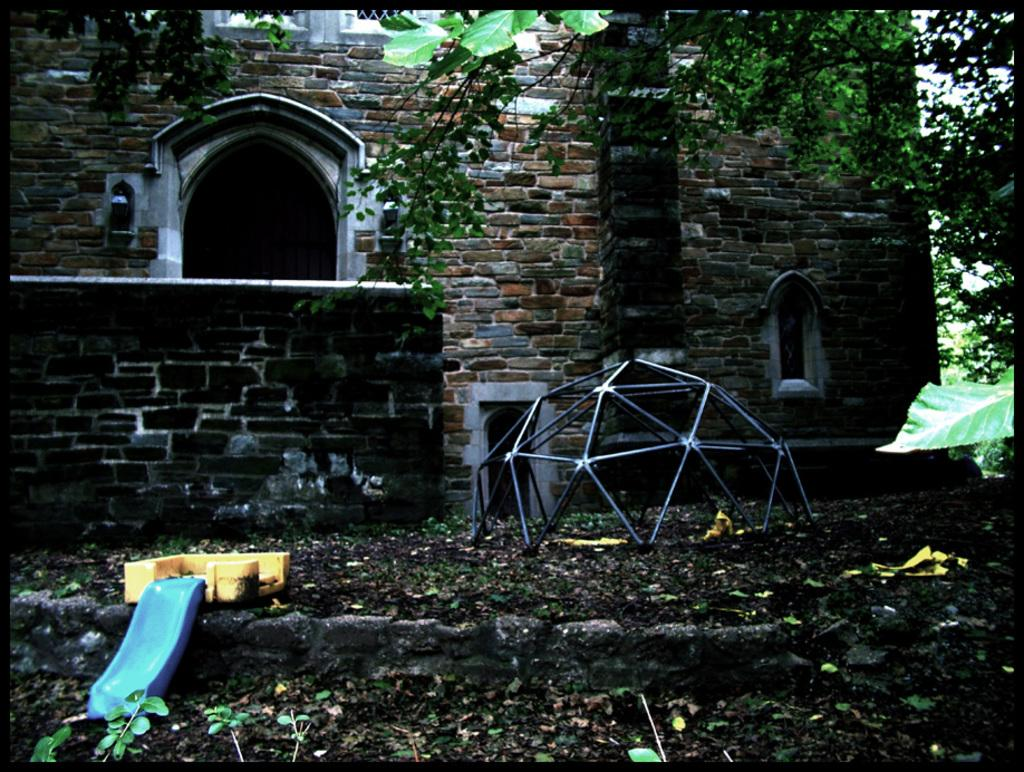What type of surface can be seen in the image? Ground is visible in the image. What is present on the ground in the image? Dry leaves are present on the ground. What type of vegetation is visible in the image? There are plants in the image. Can you describe the objects in the image? There are objects in the image, but their specific nature is not mentioned in the facts. What architectural features can be seen in the image? There is a wall with windows and a door in the image. What is visible in the background of the image? There are plants and trees in the background of the image. What part of the natural environment is visible in the image? The sky is visible in the image. What month is it in the image? The month is not mentioned in the facts, so it cannot be determined from the image. What type of destruction can be seen in the image? There is no destruction present in the image; it features a wall with windows, a door, plants, trees, and the sky. 